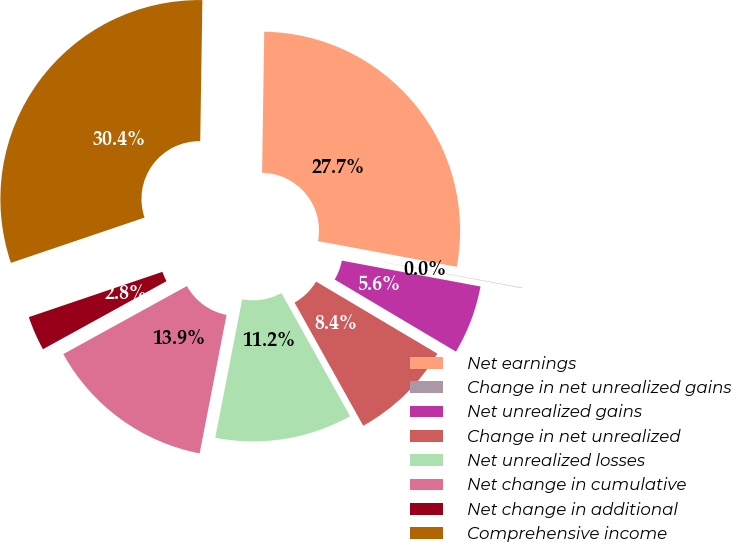<chart> <loc_0><loc_0><loc_500><loc_500><pie_chart><fcel>Net earnings<fcel>Change in net unrealized gains<fcel>Net unrealized gains<fcel>Change in net unrealized<fcel>Net unrealized losses<fcel>Net change in cumulative<fcel>Net change in additional<fcel>Comprehensive income<nl><fcel>27.66%<fcel>0.03%<fcel>5.59%<fcel>8.37%<fcel>11.15%<fcel>13.93%<fcel>2.81%<fcel>30.44%<nl></chart> 